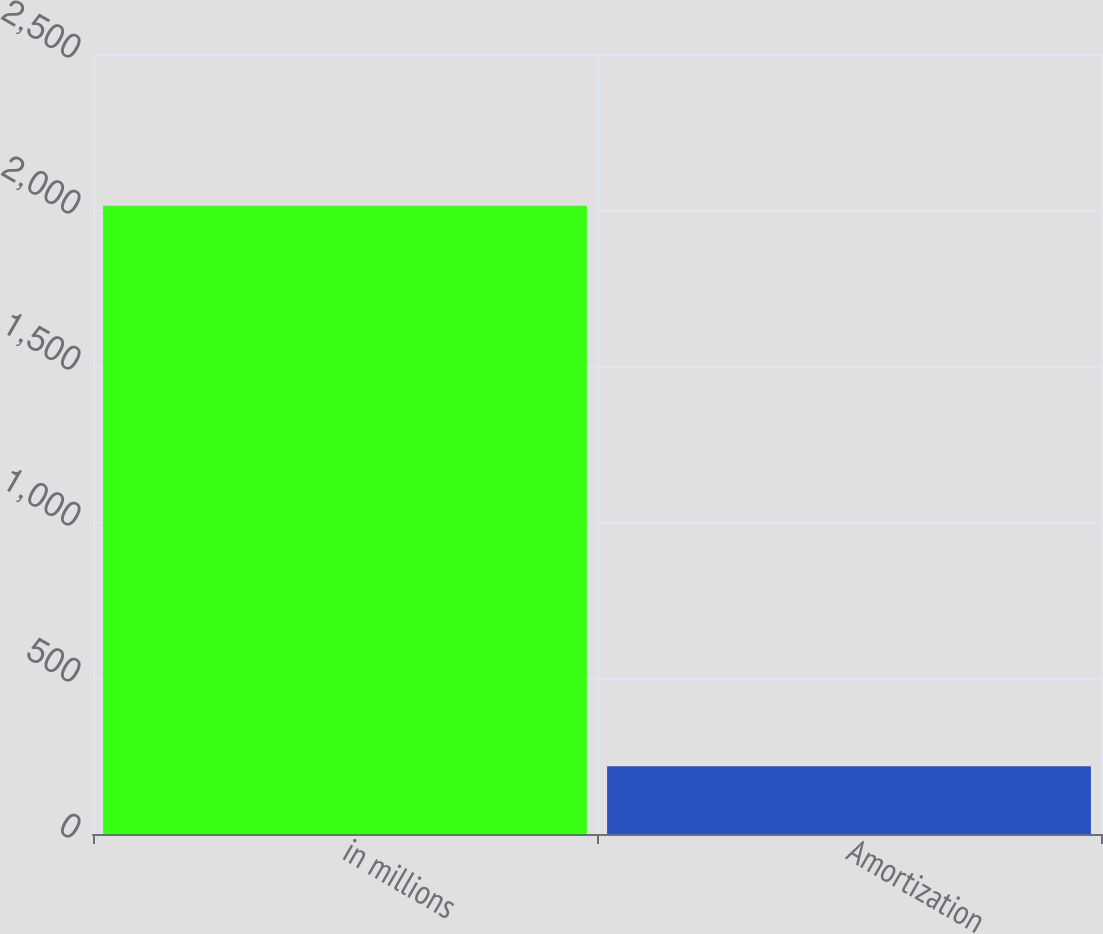<chart> <loc_0><loc_0><loc_500><loc_500><bar_chart><fcel>in millions<fcel>Amortization<nl><fcel>2014<fcel>217<nl></chart> 